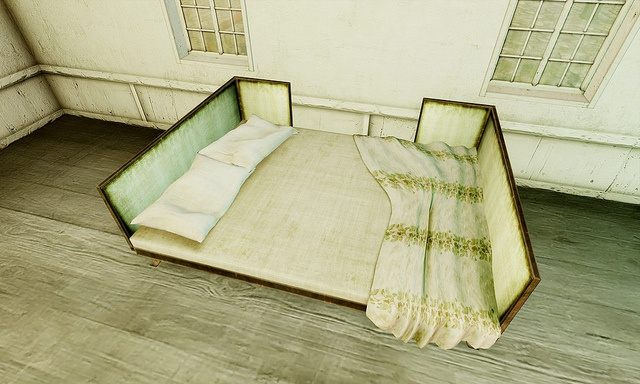Describe the objects in this image and their specific colors. I can see a bed in darkgreen, beige, and tan tones in this image. 